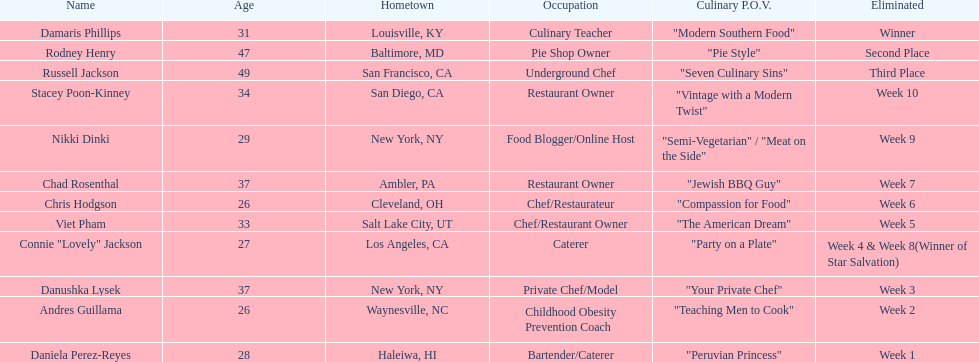Which participant's cooking perspective had a more extended explanation than "vintage with a contemporary twist"? Nikki Dinki. 